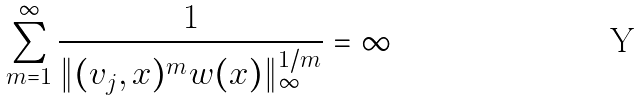<formula> <loc_0><loc_0><loc_500><loc_500>\sum _ { m = 1 } ^ { \infty } \frac { 1 } { { \| ( v _ { j } , x ) ^ { m } w ( x ) \| _ { \infty } ^ { 1 / m } } } = \infty</formula> 